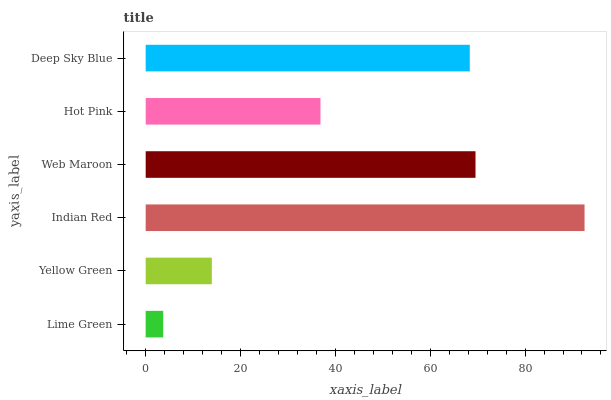Is Lime Green the minimum?
Answer yes or no. Yes. Is Indian Red the maximum?
Answer yes or no. Yes. Is Yellow Green the minimum?
Answer yes or no. No. Is Yellow Green the maximum?
Answer yes or no. No. Is Yellow Green greater than Lime Green?
Answer yes or no. Yes. Is Lime Green less than Yellow Green?
Answer yes or no. Yes. Is Lime Green greater than Yellow Green?
Answer yes or no. No. Is Yellow Green less than Lime Green?
Answer yes or no. No. Is Deep Sky Blue the high median?
Answer yes or no. Yes. Is Hot Pink the low median?
Answer yes or no. Yes. Is Web Maroon the high median?
Answer yes or no. No. Is Indian Red the low median?
Answer yes or no. No. 